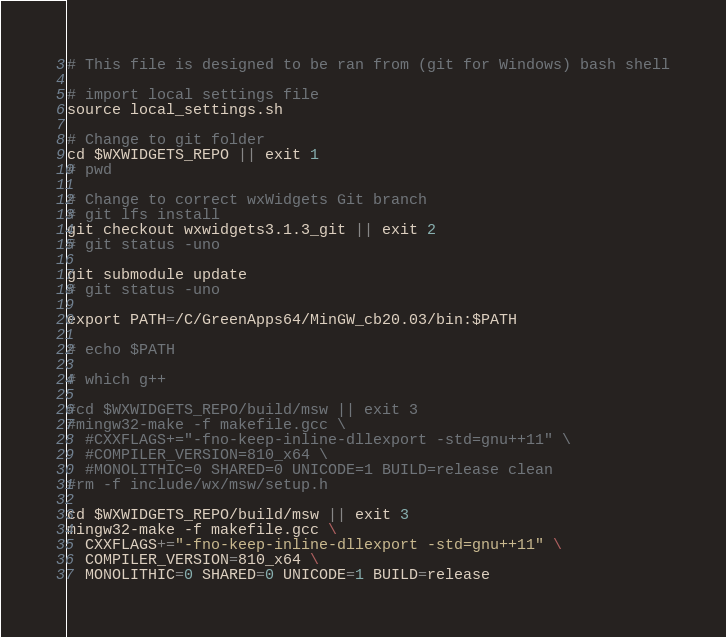Convert code to text. <code><loc_0><loc_0><loc_500><loc_500><_Bash_># This file is designed to be ran from (git for Windows) bash shell

# import local settings file
source local_settings.sh

# Change to git folder
cd $WXWIDGETS_REPO || exit 1
# pwd

# Change to correct wxWidgets Git branch
# git lfs install
git checkout wxwidgets3.1.3_git || exit 2
# git status -uno

git submodule update
# git status -uno

export PATH=/C/GreenApps64/MinGW_cb20.03/bin:$PATH

# echo $PATH

# which g++

#cd $WXWIDGETS_REPO/build/msw || exit 3
#mingw32-make -f makefile.gcc \
  #CXXFLAGS+="-fno-keep-inline-dllexport -std=gnu++11" \
  #COMPILER_VERSION=810_x64 \
  #MONOLITHIC=0 SHARED=0 UNICODE=1 BUILD=release clean
#rm -f include/wx/msw/setup.h

cd $WXWIDGETS_REPO/build/msw || exit 3
mingw32-make -f makefile.gcc \
  CXXFLAGS+="-fno-keep-inline-dllexport -std=gnu++11" \
  COMPILER_VERSION=810_x64 \
  MONOLITHIC=0 SHARED=0 UNICODE=1 BUILD=release
</code> 